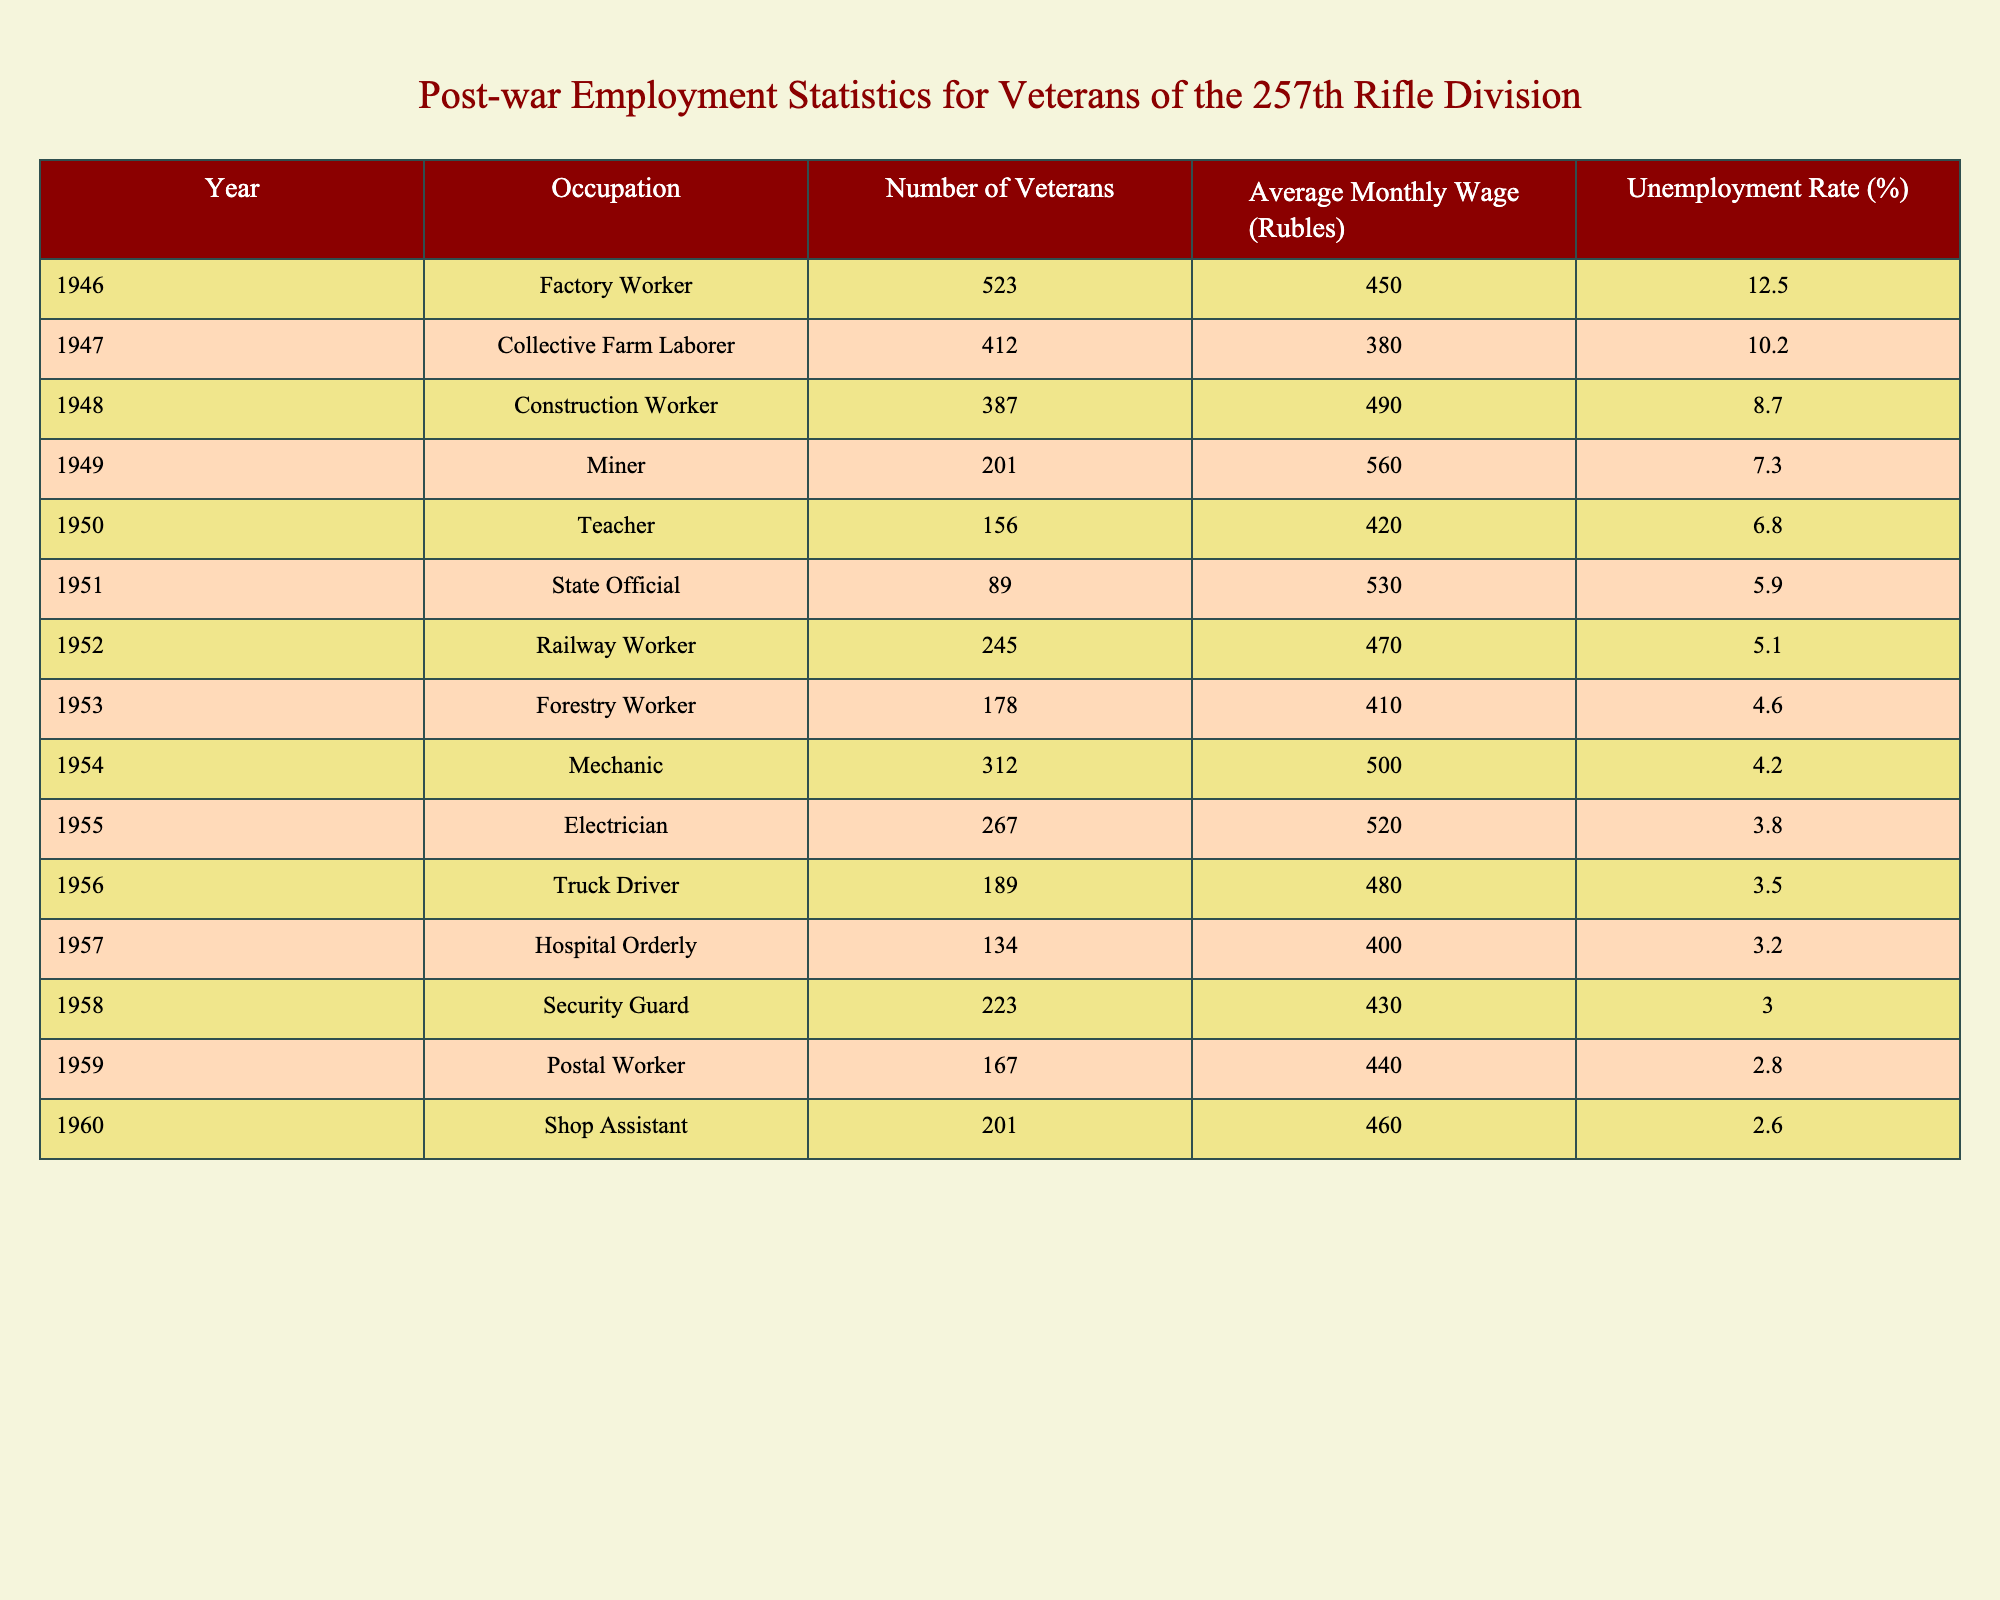What was the unemployment rate of veterans in 1960? According to the table, the unemployment rate for the year 1960 is listed under the corresponding year. Looking at the 1960 row, the unemployment rate is 2.6%.
Answer: 2.6% Which occupation had the highest number of veterans employed in 1946? In the year 1946, the table lists the number of veterans by occupation. The "Factory Worker" occupation has the highest count of 523 veterans.
Answer: Factory Worker What is the average monthly wage of teachers compared to factory workers in 1950 and 1946? The average monthly wage for teachers in 1950 is 420 Rubles, and for factory workers in 1946, it is 450 Rubles. Comparing these two values, teachers earn 30 Rubles less than factory workers.
Answer: Teachers earn 30 Rubles less In how many years did the unemployment rate drop below 5%? The table lists unemployment rates for various years. By reviewing the rates, we identify that from 1955 onwards, the unemployment rate is below 5% (1955, 1956, 1957, 1958, 1959, 1960). Counting these years gives us a total of six years where the rate is below 5%.
Answer: 6 years What was the difference between the average monthly wages for miners in 1949 and electrical workers in 1955? For miners in 1949, the average wage is 560 Rubles, and for electricians in 1955, it is 520 Rubles. The difference in wages is 560 - 520 = 40 Rubles.
Answer: 40 Rubles Which occupation had the lowest unemployment rate in 1958? The table shows unemployment rates for various occupations in different years. In 1958, the occupation with the lowest unemployment rate is "Security Guard" at 3.0%.
Answer: Security Guard What was the trend of unemployment rates from 1946 to 1960? By observing the unemployment rates listed from 1946 to 1960, we notice a decrease over the years. Starting at 12.5% in 1946, the rates continually decreased to 2.6% in 1960. This indicates a downward trend.
Answer: Downward trend How many more factory workers were there compared to collective farm laborers in 1947? In 1947, the table lists 523 factory workers and 412 collective farm laborers. The difference is calculated as 523 - 412 = 111 more factory workers.
Answer: 111 more factory workers What was the average monthly wage across all occupations in 1954? To find the average monthly wage for 1954, we need to consider the wages for various occupations listed. Summing the values (500 + 470 + 410 + ...) and dividing by the number of occupations (in this case, 10) gives us the average monthly wage for 1954. The total comes out to approximately 475 Rubles.
Answer: 475 Rubles Were there more veterans employed in construction or teaching in 1950? By comparing the numbers from the table for 1950, teaching had 156 veterans while construction has no listed data, which leads to comparing with the previous year when construction was 387. Therefore, 387 construction workers employed exceeds the number of teachers.
Answer: Yes, construction had more veterans 